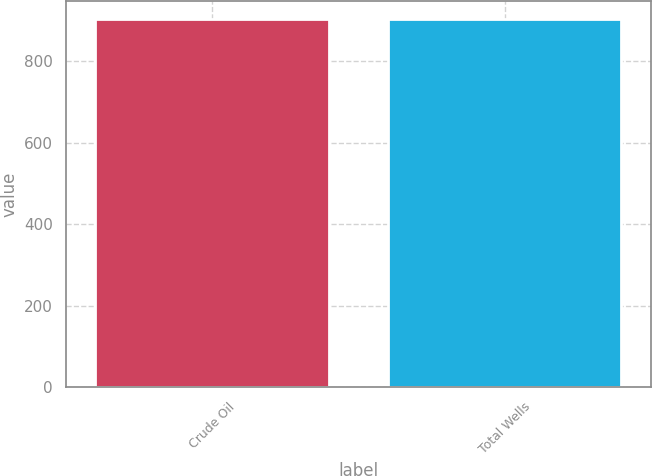Convert chart to OTSL. <chart><loc_0><loc_0><loc_500><loc_500><bar_chart><fcel>Crude Oil<fcel>Total Wells<nl><fcel>903<fcel>903.1<nl></chart> 